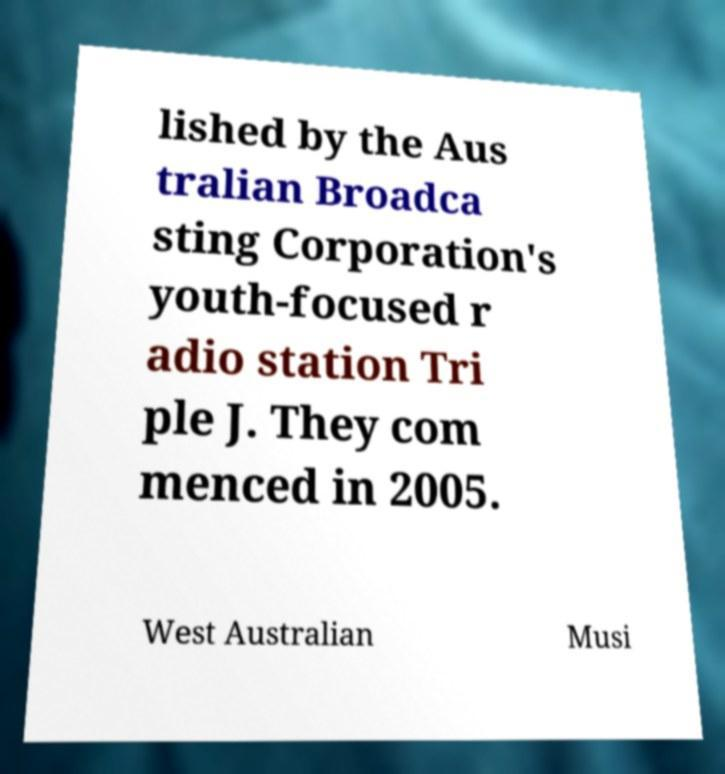I need the written content from this picture converted into text. Can you do that? lished by the Aus tralian Broadca sting Corporation's youth-focused r adio station Tri ple J. They com menced in 2005. West Australian Musi 